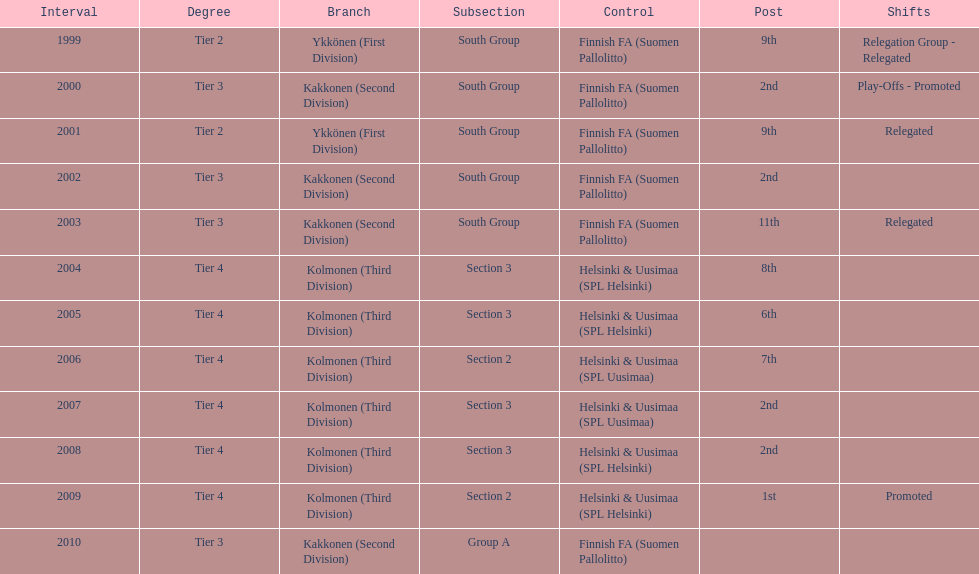What is the first tier listed? Tier 2. 